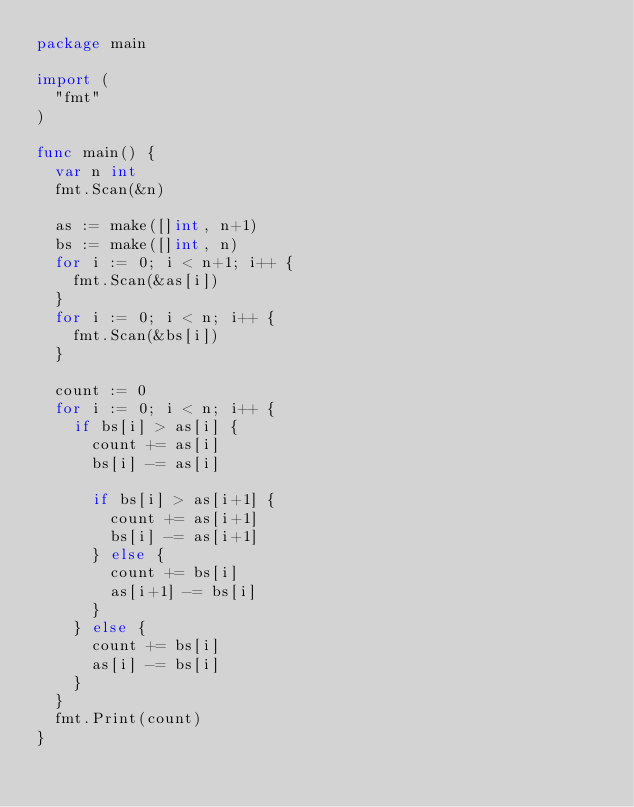<code> <loc_0><loc_0><loc_500><loc_500><_Go_>package main

import (
	"fmt"
)

func main() {
	var n int
	fmt.Scan(&n)

	as := make([]int, n+1)
	bs := make([]int, n)
	for i := 0; i < n+1; i++ {
		fmt.Scan(&as[i])
	}
	for i := 0; i < n; i++ {
		fmt.Scan(&bs[i])
	}

	count := 0
	for i := 0; i < n; i++ {
		if bs[i] > as[i] {
			count += as[i]
			bs[i] -= as[i]

			if bs[i] > as[i+1] {
				count += as[i+1]
				bs[i] -= as[i+1]
			} else {
				count += bs[i]
				as[i+1] -= bs[i]
			}
		} else {
			count += bs[i]
			as[i] -= bs[i]
		}
	}
	fmt.Print(count)
}
</code> 